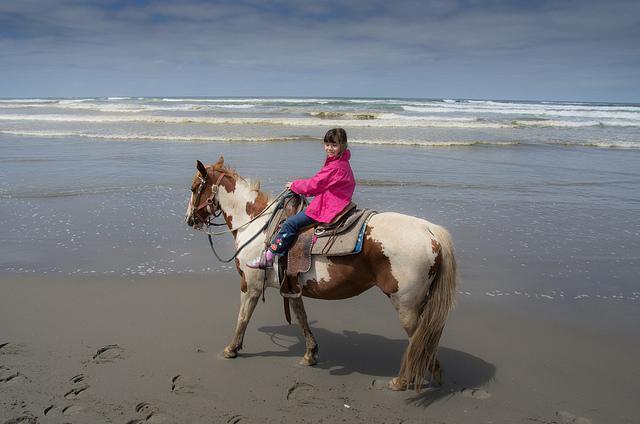How many people are looking towards the photographer?
Give a very brief answer. 1. How many people are there?
Give a very brief answer. 1. 